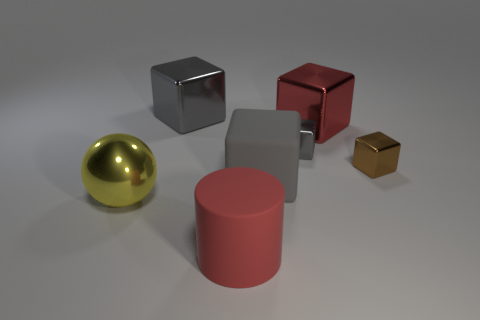There is a yellow object; what shape is it?
Your answer should be compact. Sphere. Are there any cubes that have the same color as the rubber cylinder?
Keep it short and to the point. Yes. Are there more large cubes that are in front of the brown cube than red metal spheres?
Ensure brevity in your answer.  Yes. There is a brown thing; does it have the same shape as the small shiny thing behind the brown shiny thing?
Keep it short and to the point. Yes. Is there a large blue metallic cylinder?
Your response must be concise. No. How many small things are either metallic cubes or cylinders?
Ensure brevity in your answer.  2. Are there more big red things on the left side of the large red metallic cube than gray metallic things that are in front of the metallic sphere?
Your answer should be very brief. Yes. Is the yellow object made of the same material as the big red thing behind the large metal sphere?
Provide a succinct answer. Yes. What is the color of the metal ball?
Give a very brief answer. Yellow. The rubber thing that is behind the large yellow metal sphere has what shape?
Provide a succinct answer. Cube. 